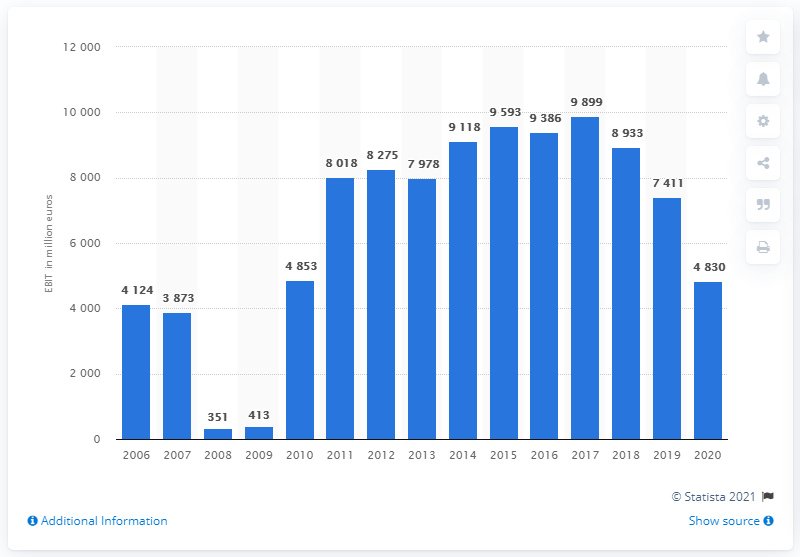Indicate a few pertinent items in this graphic. In 2020, the BMW Group's global EBIT was 4,830. 